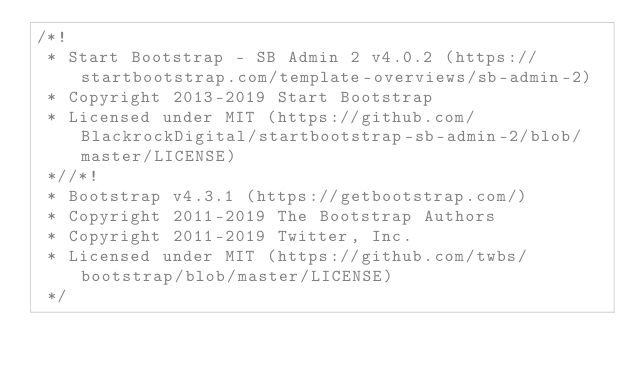Convert code to text. <code><loc_0><loc_0><loc_500><loc_500><_CSS_>/*!
 * Start Bootstrap - SB Admin 2 v4.0.2 (https://startbootstrap.com/template-overviews/sb-admin-2)
 * Copyright 2013-2019 Start Bootstrap
 * Licensed under MIT (https://github.com/BlackrockDigital/startbootstrap-sb-admin-2/blob/master/LICENSE)
 *//*!
 * Bootstrap v4.3.1 (https://getbootstrap.com/)
 * Copyright 2011-2019 The Bootstrap Authors
 * Copyright 2011-2019 Twitter, Inc.
 * Licensed under MIT (https://github.com/twbs/bootstrap/blob/master/LICENSE)
 */</code> 